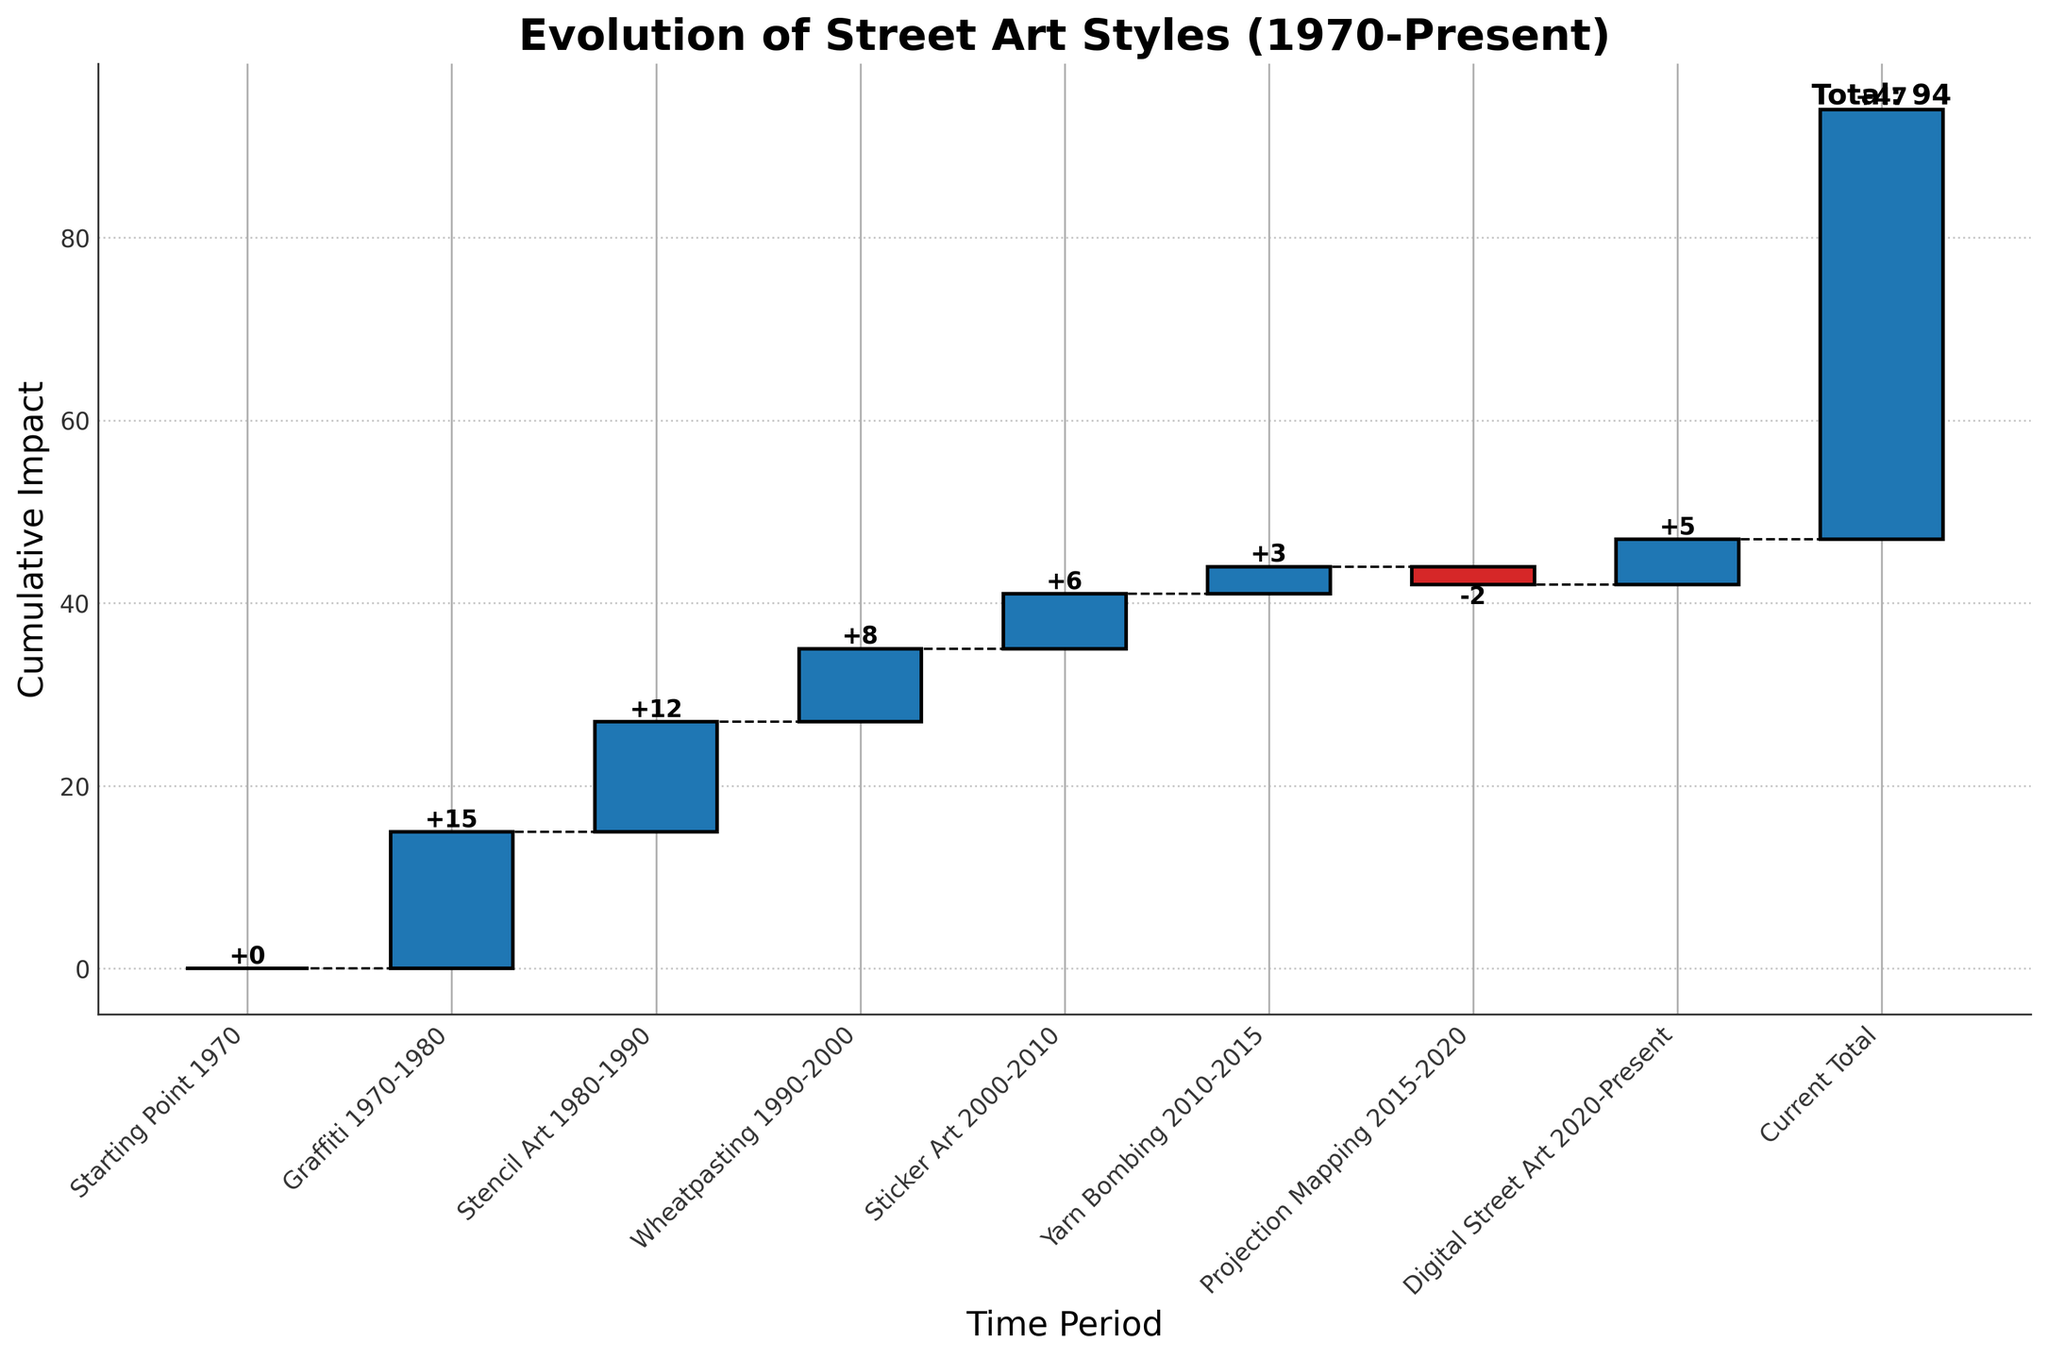What's the title of the chart? The title is located at the top of the chart in a larger and bolder font. It reads "Evolution of Street Art Styles (1970-Present)."
Answer: Evolution of Street Art Styles (1970-Present) What does the x-axis represent in this chart? The x-axis in this chart represents the different time periods and categories of street art styles, labeled from left to right starting from "Starting Point 1970" to "Current Total."
Answer: Time periods and categories of street art styles Which street art style had the highest positive impact? By visually examining the bars' heights, the "Graffiti 1970-1980" period has the highest positive value.
Answer: Graffiti 1970-1980 How many time periods are depicted in the chart? Count the number of bars on the x-axis, including all categories and ending points. There are 8 time periods including "Starting Point 1970" and "Current Total."
Answer: 8 What's the cumulative impact just before the "Current Total"? Look at the label just below the "Current Total" bar. The cumulative impact before the "Current Total" is indicated at the end of the "Digital Street Art 2020-Present" bar, which is 42.
Answer: 42 Which time period had the only negative impact on the evolution? Identify the bar that is red in color (negative values) among the rest, which belongs to the "Projection Mapping 2015-2020" period with a value of -2.
Answer: Projection Mapping 2015-2020 How much impact did "Stencil Art 1980-1990" period add to the total? Look at the height of the bar labeled "Stencil Art 1980-1990." The value indicated on the top of the bar is +12.
Answer: 12 What period followed "Graffiti 1970-1980"? Observe the position of the bars on the x-axis right after the "Graffiti 1970-1980" bar. The following "Stencil Art 1980-1990" bar signifies its consecutive period.
Answer: Stencil Art 1980-1990 What's the difference between "Wheatpasting 1990-2000" and "Digital Street Art 2020-Present" in terms of their impact? Calculate the difference between the two values provided for each period. Subtract "Wheatpasting" (8) from "Digital Street Art" (5), so 5 - 8 = -3.
Answer: -3 